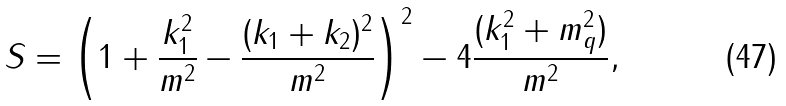<formula> <loc_0><loc_0><loc_500><loc_500>S = \left ( 1 + \frac { { k } ^ { 2 } _ { 1 } } { m ^ { 2 } } - \frac { ( { k } _ { 1 } + { k } _ { 2 } ) ^ { 2 } } { m ^ { 2 } } \right ) ^ { 2 } - 4 \frac { ( { k } _ { 1 } ^ { 2 } + m _ { q } ^ { 2 } ) } { m ^ { 2 } } ,</formula> 